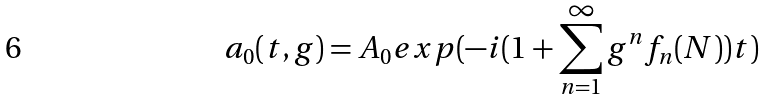<formula> <loc_0><loc_0><loc_500><loc_500>a _ { 0 } ( t , g ) = A _ { 0 } e x p ( - i ( 1 + \sum _ { n = 1 } ^ { \infty } g ^ { n } f _ { n } ( N ) ) t )</formula> 